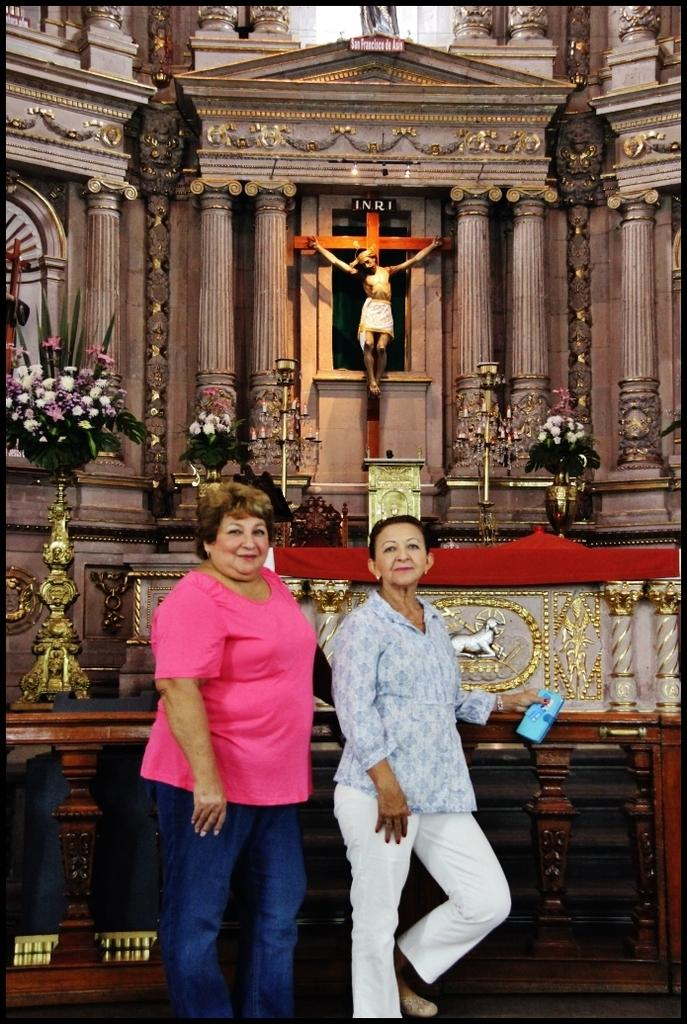How many women are in the image? There are two women in the image. Where are the women located? The women are standing inside a church. What can be seen in the background of the image? Jesus is visible in the background of the image. What decorative items are present in the image? There are flower vases in the image. What architectural features can be seen in the image? There are pillars in the image. How is the image framed? The image has borders. What type of design is visible on the rat in the image? There is no rat present in the image. How many times has the image been folded? The image has not been folded, as it is a digital representation or a photograph. 